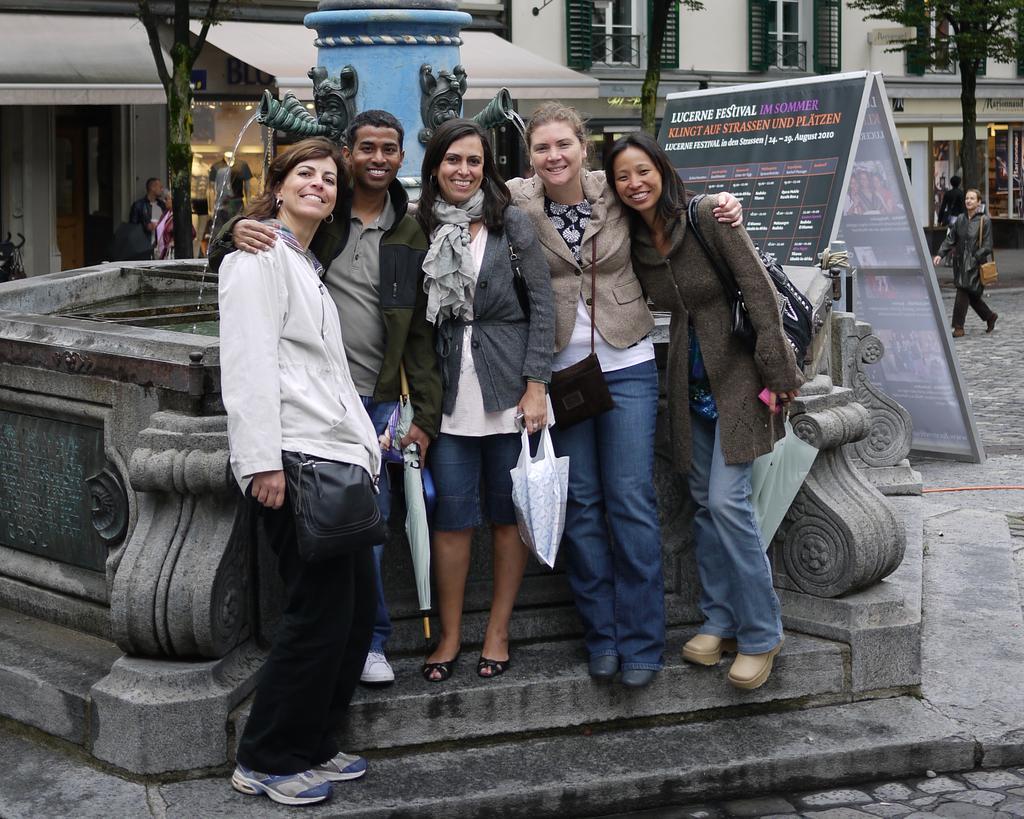Could you give a brief overview of what you see in this image? In this image, there are five people standing and smiling. Behind these people, there is a water fountain, buildings, trees, a hoarding and two people standing in front a building. On the right side of the image, I can see a person walking. 